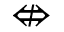<formula> <loc_0><loc_0><loc_500><loc_500>\ n L e f t r i g h t a r r o w</formula> 